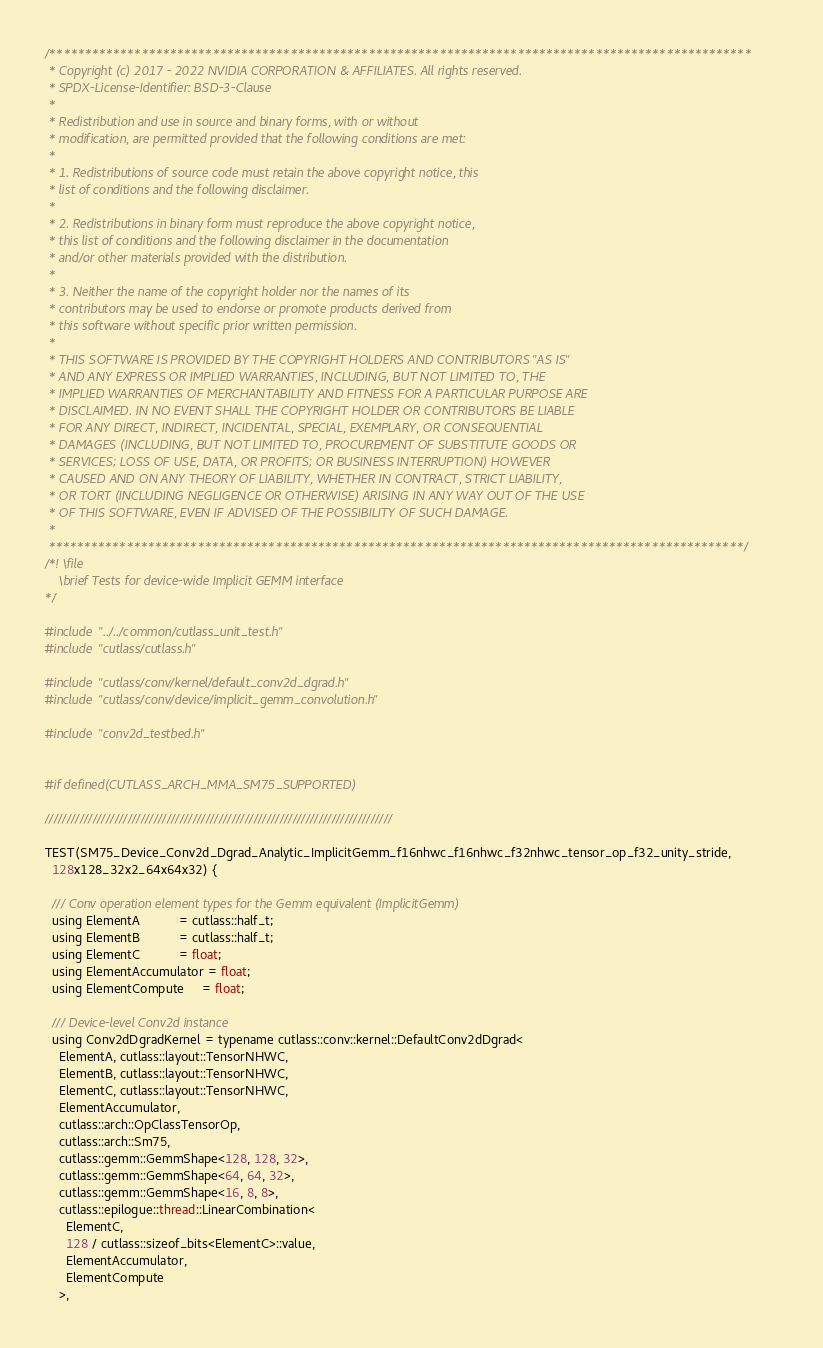Convert code to text. <code><loc_0><loc_0><loc_500><loc_500><_Cuda_>/***************************************************************************************************
 * Copyright (c) 2017 - 2022 NVIDIA CORPORATION & AFFILIATES. All rights reserved.
 * SPDX-License-Identifier: BSD-3-Clause
 *
 * Redistribution and use in source and binary forms, with or without
 * modification, are permitted provided that the following conditions are met:
 *
 * 1. Redistributions of source code must retain the above copyright notice, this
 * list of conditions and the following disclaimer.
 *
 * 2. Redistributions in binary form must reproduce the above copyright notice,
 * this list of conditions and the following disclaimer in the documentation
 * and/or other materials provided with the distribution.
 *
 * 3. Neither the name of the copyright holder nor the names of its
 * contributors may be used to endorse or promote products derived from
 * this software without specific prior written permission.
 *
 * THIS SOFTWARE IS PROVIDED BY THE COPYRIGHT HOLDERS AND CONTRIBUTORS "AS IS"
 * AND ANY EXPRESS OR IMPLIED WARRANTIES, INCLUDING, BUT NOT LIMITED TO, THE
 * IMPLIED WARRANTIES OF MERCHANTABILITY AND FITNESS FOR A PARTICULAR PURPOSE ARE
 * DISCLAIMED. IN NO EVENT SHALL THE COPYRIGHT HOLDER OR CONTRIBUTORS BE LIABLE
 * FOR ANY DIRECT, INDIRECT, INCIDENTAL, SPECIAL, EXEMPLARY, OR CONSEQUENTIAL
 * DAMAGES (INCLUDING, BUT NOT LIMITED TO, PROCUREMENT OF SUBSTITUTE GOODS OR
 * SERVICES; LOSS OF USE, DATA, OR PROFITS; OR BUSINESS INTERRUPTION) HOWEVER
 * CAUSED AND ON ANY THEORY OF LIABILITY, WHETHER IN CONTRACT, STRICT LIABILITY,
 * OR TORT (INCLUDING NEGLIGENCE OR OTHERWISE) ARISING IN ANY WAY OUT OF THE USE
 * OF THIS SOFTWARE, EVEN IF ADVISED OF THE POSSIBILITY OF SUCH DAMAGE.
 *
 **************************************************************************************************/
/*! \file
    \brief Tests for device-wide Implicit GEMM interface
*/

#include "../../common/cutlass_unit_test.h"
#include "cutlass/cutlass.h"

#include "cutlass/conv/kernel/default_conv2d_dgrad.h"
#include "cutlass/conv/device/implicit_gemm_convolution.h"

#include "conv2d_testbed.h"


#if defined(CUTLASS_ARCH_MMA_SM75_SUPPORTED)

////////////////////////////////////////////////////////////////////////////////

TEST(SM75_Device_Conv2d_Dgrad_Analytic_ImplicitGemm_f16nhwc_f16nhwc_f32nhwc_tensor_op_f32_unity_stride,
  128x128_32x2_64x64x32) {

  /// Conv operation element types for the Gemm equivalent (ImplicitGemm)
  using ElementA           = cutlass::half_t;
  using ElementB           = cutlass::half_t;
  using ElementC           = float;
  using ElementAccumulator = float;
  using ElementCompute     = float;

  /// Device-level Conv2d instance
  using Conv2dDgradKernel = typename cutlass::conv::kernel::DefaultConv2dDgrad<
    ElementA, cutlass::layout::TensorNHWC,
    ElementB, cutlass::layout::TensorNHWC,
    ElementC, cutlass::layout::TensorNHWC,
    ElementAccumulator,
    cutlass::arch::OpClassTensorOp,
    cutlass::arch::Sm75,
    cutlass::gemm::GemmShape<128, 128, 32>,
    cutlass::gemm::GemmShape<64, 64, 32>,
    cutlass::gemm::GemmShape<16, 8, 8>,
    cutlass::epilogue::thread::LinearCombination<
      ElementC,
      128 / cutlass::sizeof_bits<ElementC>::value,
      ElementAccumulator,
      ElementCompute
    >,</code> 